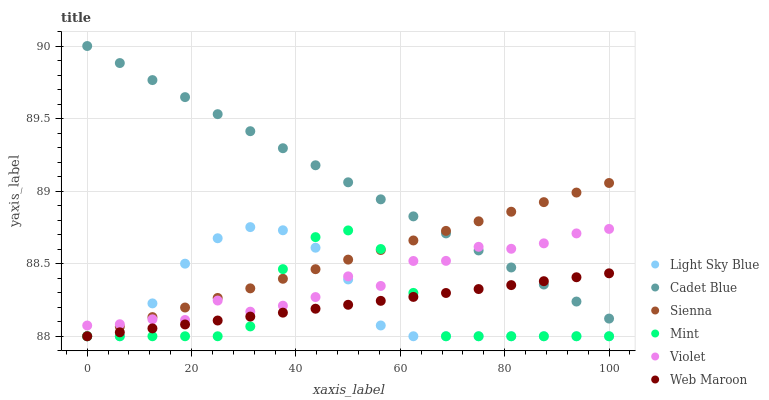Does Mint have the minimum area under the curve?
Answer yes or no. Yes. Does Cadet Blue have the maximum area under the curve?
Answer yes or no. Yes. Does Web Maroon have the minimum area under the curve?
Answer yes or no. No. Does Web Maroon have the maximum area under the curve?
Answer yes or no. No. Is Cadet Blue the smoothest?
Answer yes or no. Yes. Is Violet the roughest?
Answer yes or no. Yes. Is Web Maroon the smoothest?
Answer yes or no. No. Is Web Maroon the roughest?
Answer yes or no. No. Does Web Maroon have the lowest value?
Answer yes or no. Yes. Does Violet have the lowest value?
Answer yes or no. No. Does Cadet Blue have the highest value?
Answer yes or no. Yes. Does Sienna have the highest value?
Answer yes or no. No. Is Light Sky Blue less than Cadet Blue?
Answer yes or no. Yes. Is Cadet Blue greater than Mint?
Answer yes or no. Yes. Does Mint intersect Violet?
Answer yes or no. Yes. Is Mint less than Violet?
Answer yes or no. No. Is Mint greater than Violet?
Answer yes or no. No. Does Light Sky Blue intersect Cadet Blue?
Answer yes or no. No. 